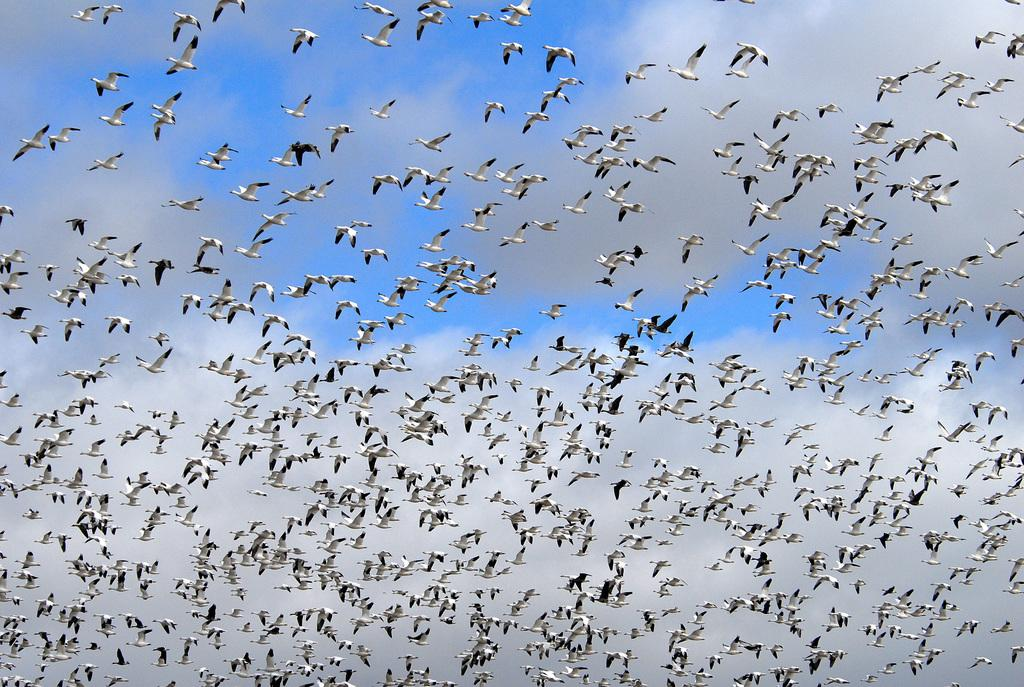What type of animals can be seen in the image? There are birds in the image. What are the birds doing in the image? The birds are flying in the air. What part of the natural environment is visible in the image? The sky is visible in the image. What is the condition of the sky in the image? The sky is cloudy in the image. What type of tooth can be seen in the image? There is no tooth present in the image; it features birds flying in the cloudy sky. How many birds are blowing in the image? There is no indication of any birds blowing in the image; they are simply flying. 